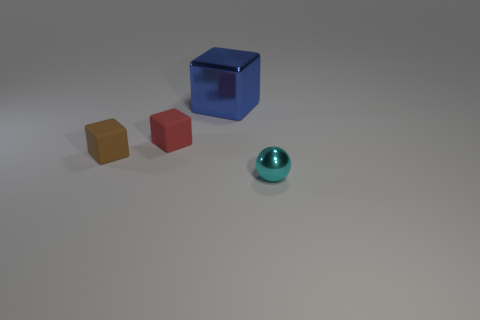Add 2 large cyan shiny objects. How many objects exist? 6 Subtract all balls. How many objects are left? 3 Add 4 brown matte objects. How many brown matte objects are left? 5 Add 2 big blue cubes. How many big blue cubes exist? 3 Subtract 0 brown cylinders. How many objects are left? 4 Subtract all red blocks. Subtract all brown objects. How many objects are left? 2 